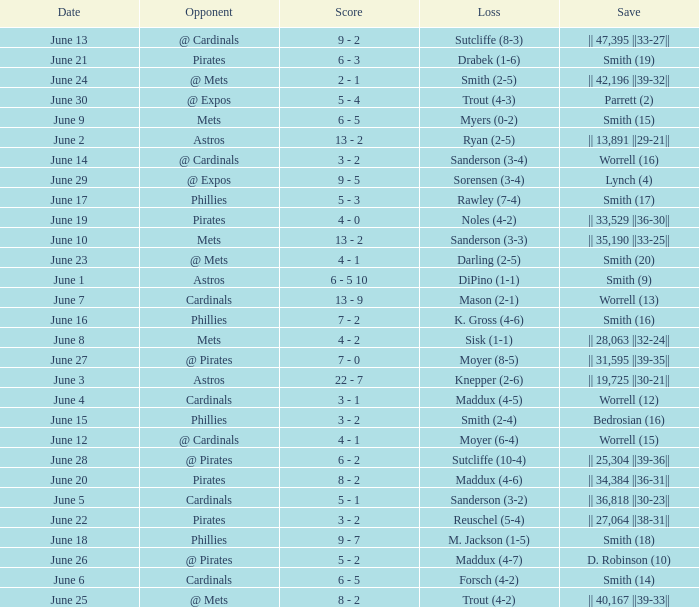On which day did the Chicago Cubs have a loss of trout (4-2)? June 25. 